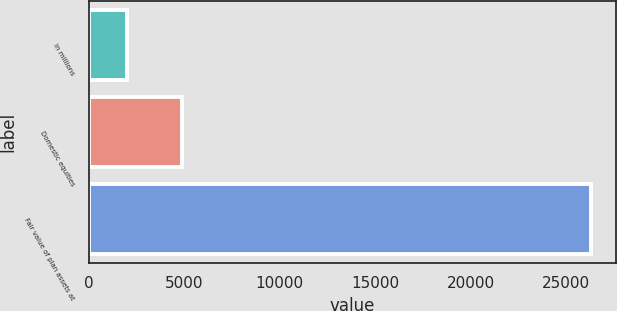<chart> <loc_0><loc_0><loc_500><loc_500><bar_chart><fcel>in millions<fcel>Domestic equities<fcel>Fair value of plan assets at<nl><fcel>2014<fcel>4878<fcel>26279<nl></chart> 